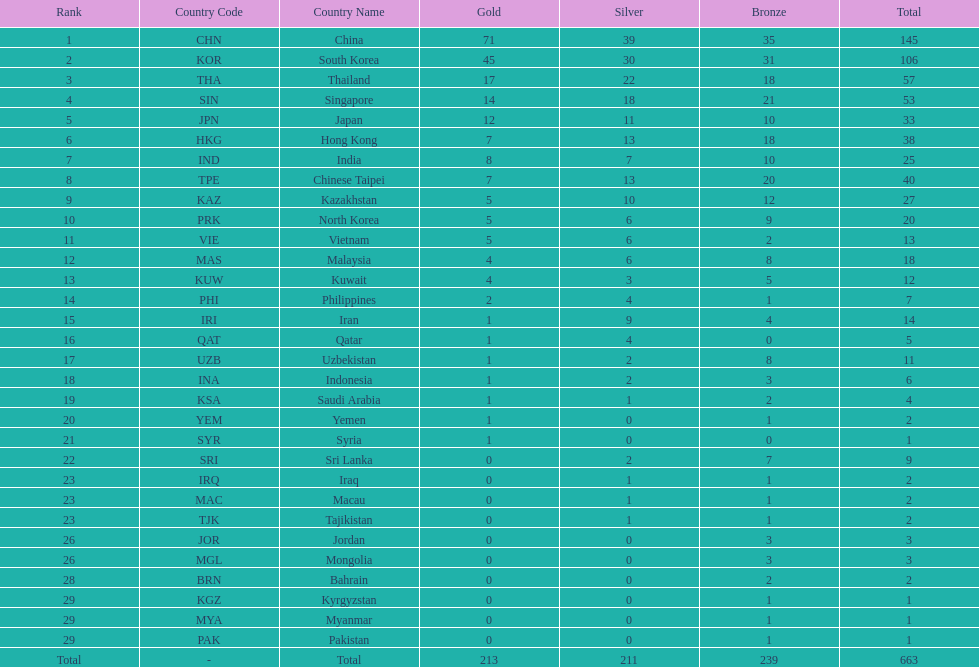How many countries have at least 10 gold medals in the asian youth games? 5. 